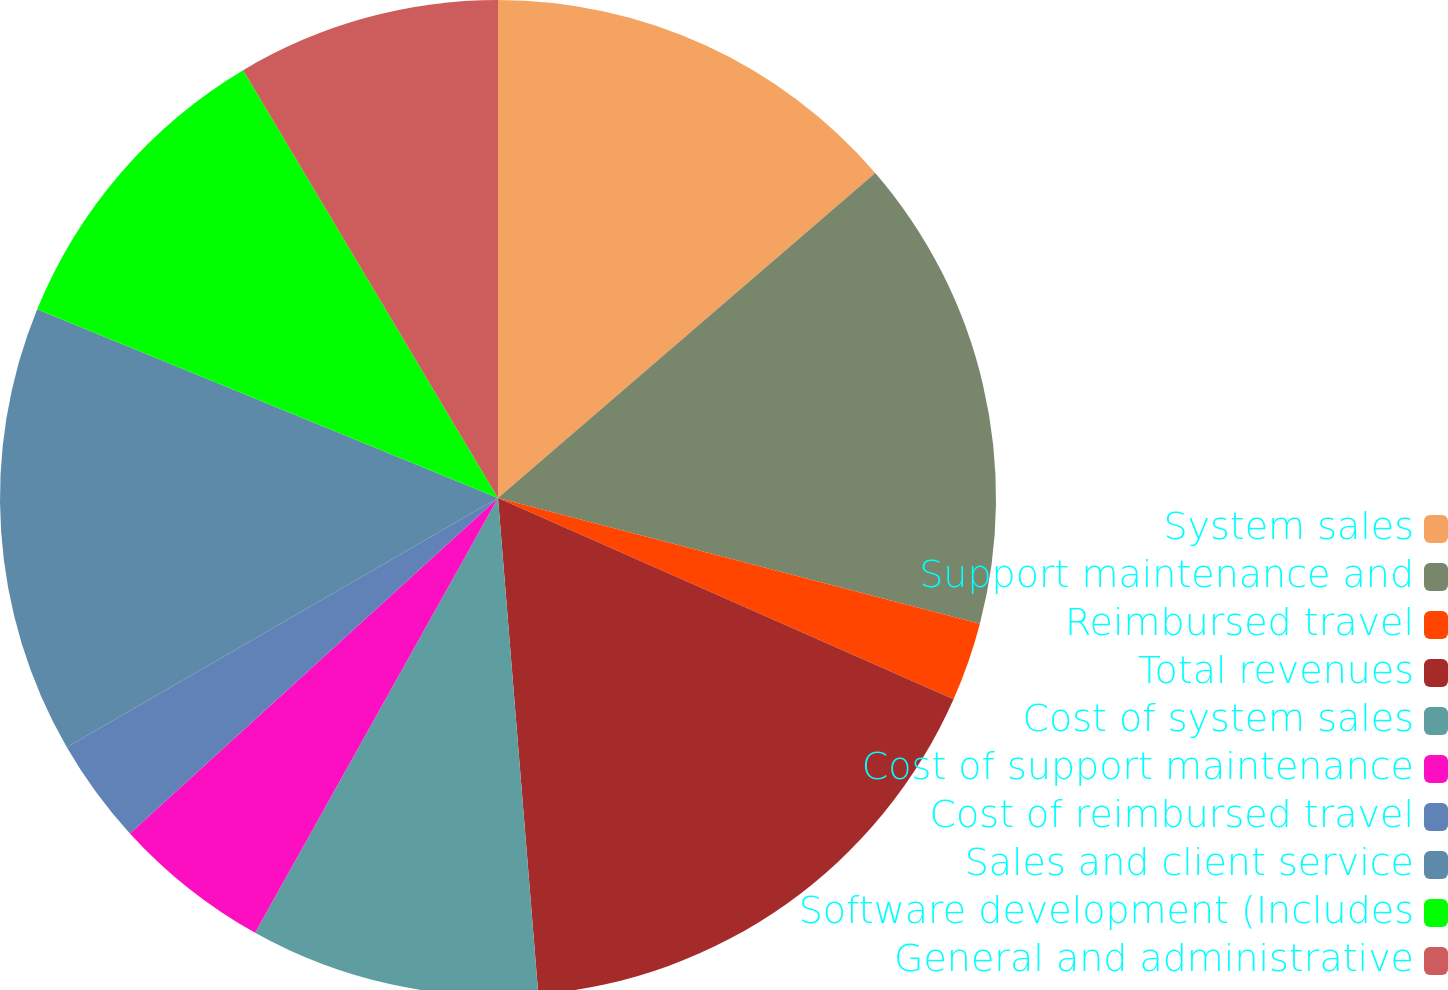Convert chart. <chart><loc_0><loc_0><loc_500><loc_500><pie_chart><fcel>System sales<fcel>Support maintenance and<fcel>Reimbursed travel<fcel>Total revenues<fcel>Cost of system sales<fcel>Cost of support maintenance<fcel>Cost of reimbursed travel<fcel>Sales and client service<fcel>Software development (Includes<fcel>General and administrative<nl><fcel>13.68%<fcel>15.38%<fcel>2.56%<fcel>17.09%<fcel>9.4%<fcel>5.13%<fcel>3.42%<fcel>14.53%<fcel>10.26%<fcel>8.55%<nl></chart> 